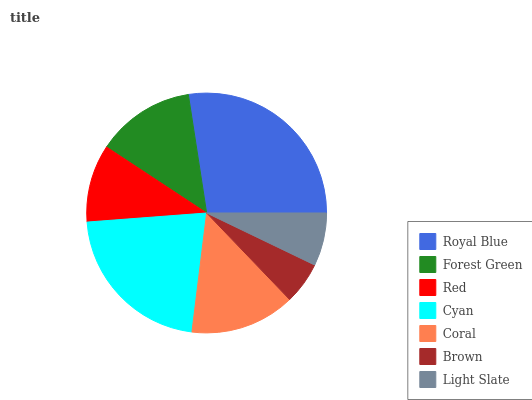Is Brown the minimum?
Answer yes or no. Yes. Is Royal Blue the maximum?
Answer yes or no. Yes. Is Forest Green the minimum?
Answer yes or no. No. Is Forest Green the maximum?
Answer yes or no. No. Is Royal Blue greater than Forest Green?
Answer yes or no. Yes. Is Forest Green less than Royal Blue?
Answer yes or no. Yes. Is Forest Green greater than Royal Blue?
Answer yes or no. No. Is Royal Blue less than Forest Green?
Answer yes or no. No. Is Forest Green the high median?
Answer yes or no. Yes. Is Forest Green the low median?
Answer yes or no. Yes. Is Red the high median?
Answer yes or no. No. Is Cyan the low median?
Answer yes or no. No. 